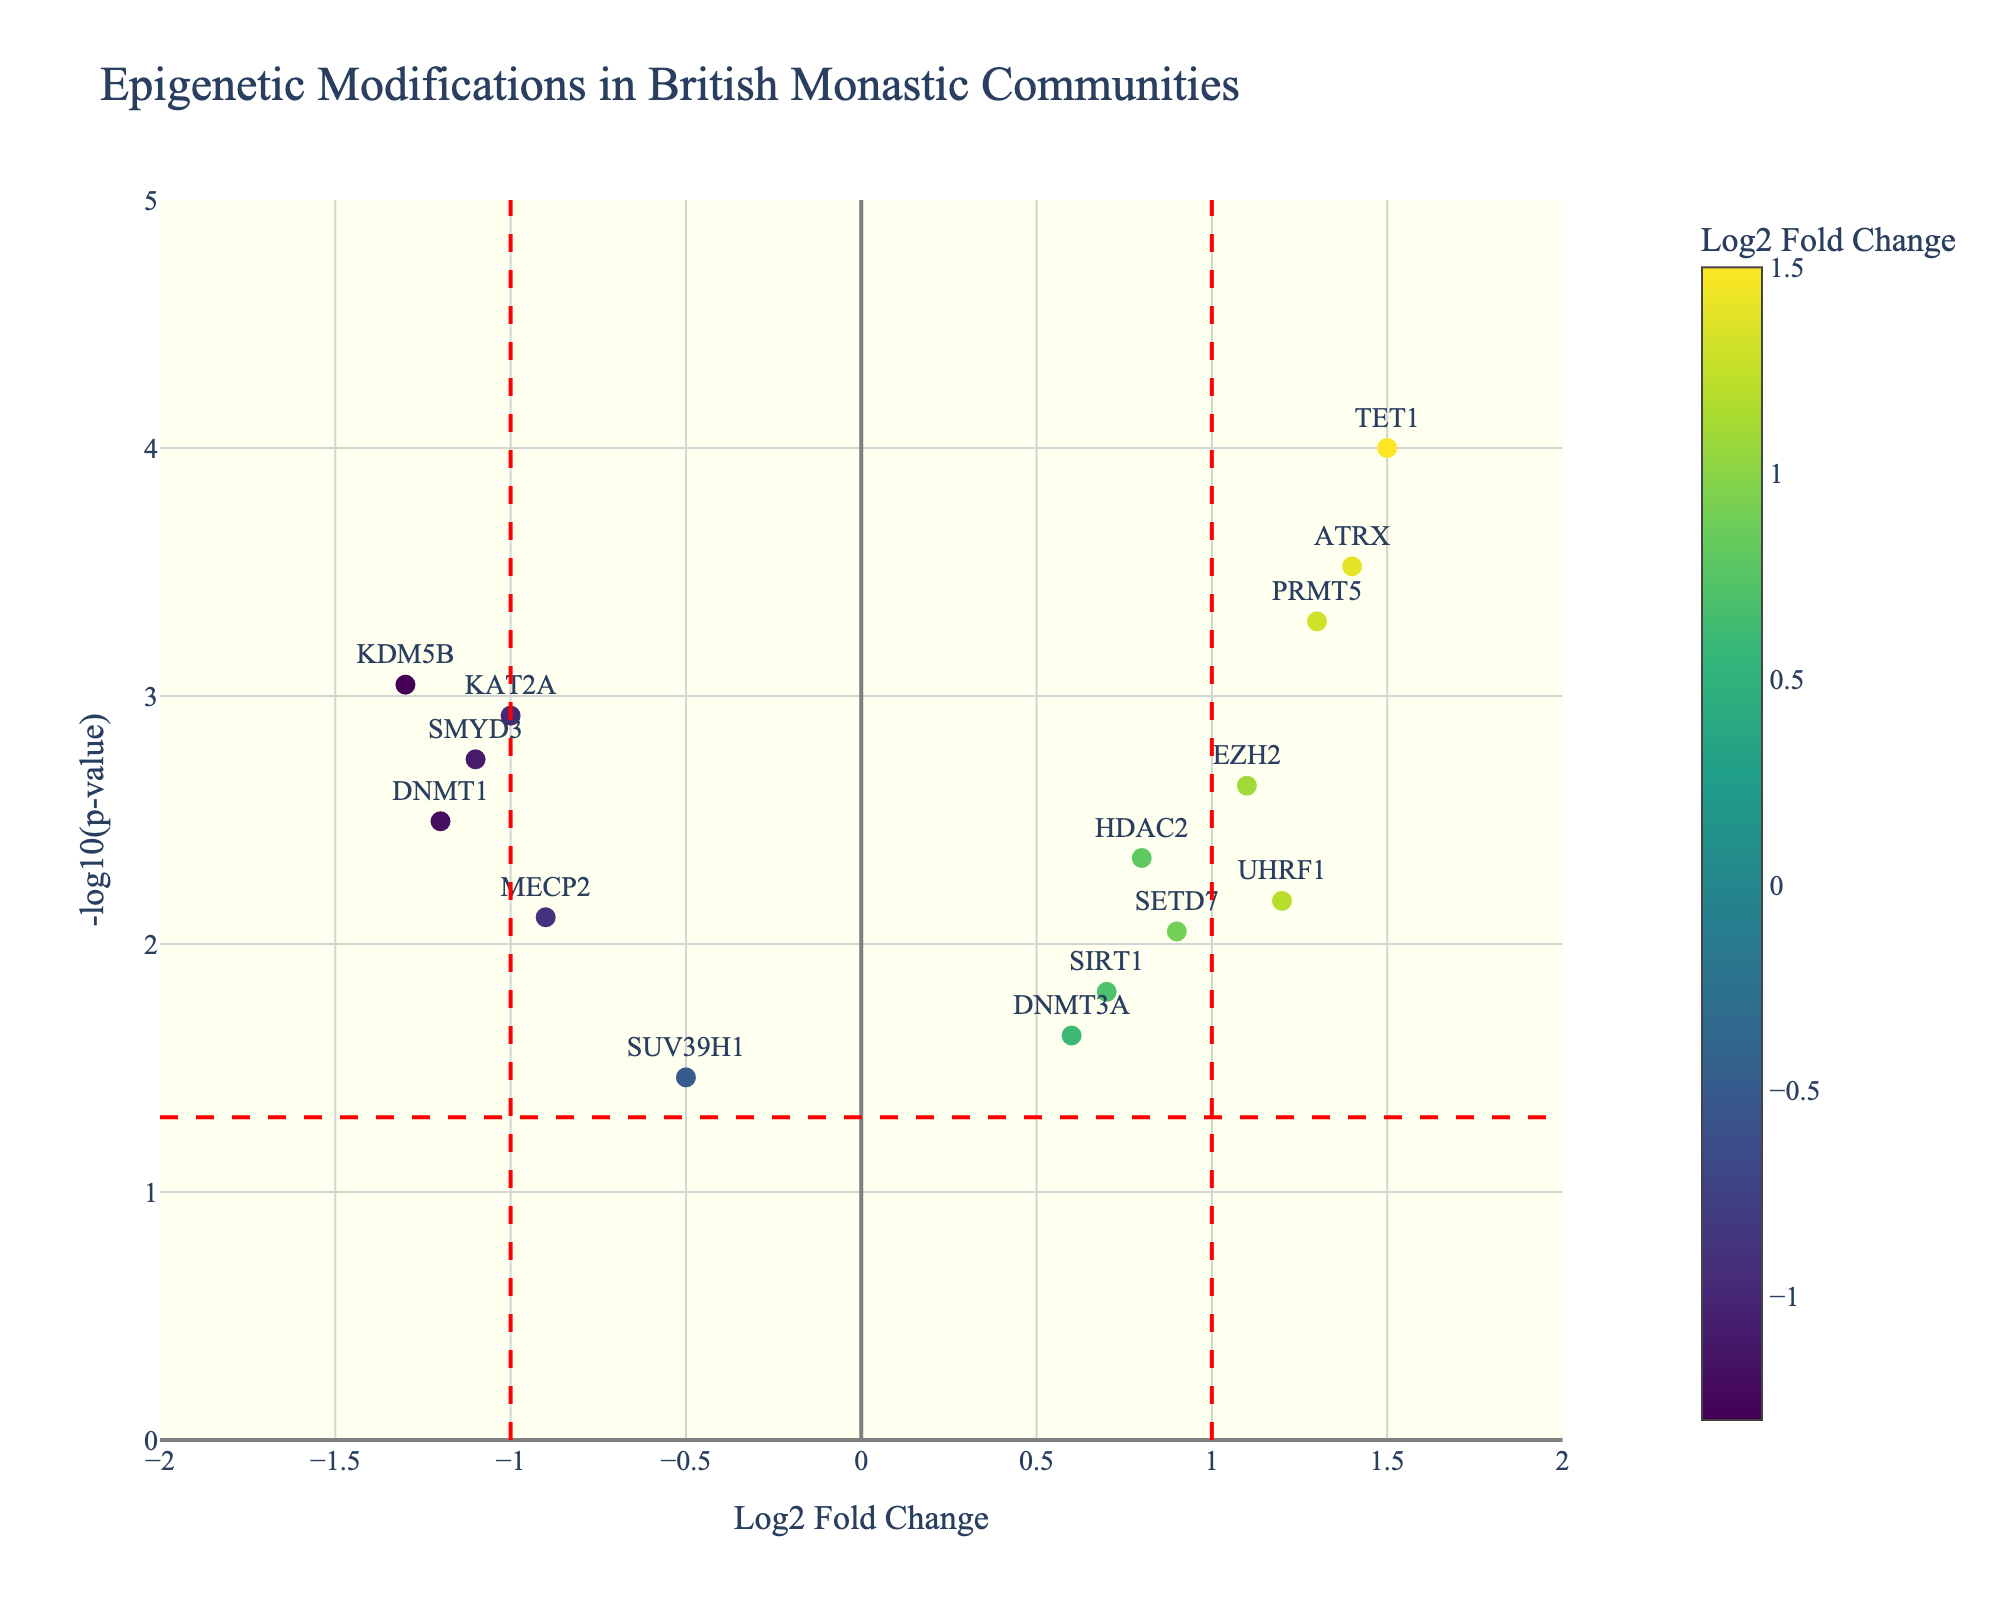Which gene has the highest -log10(p-value) and what is that value? Identify the gene with the highest value on the y-axis and read its y-coordinate. The gene TET1 has the highest -log10(p-value) value, which is around 4.
Answer: TET1, ~4 How many genes have a Log2 Fold Change greater than 1? Count the number of points situated to the right of the x=1 vertical dashed red line. From the plot, the genes with Log2 Fold Change greater than 1 are TET1, EZH2, ATRX, UHRF1, and PRMT5, totaling 5.
Answer: 5 Which gene has the lowest Log2 Fold Change and what is that value? Identify the gene with the lowest x-coordinate on the plot and read its value. The gene KDM5B has the lowest Log2 Fold Change value of -1.3.
Answer: KDM5B, -1.3 Which genes are significantly different, and how can you tell from the plot? Significant genes have a -log10(p-value) greater than -log10(0.05). These genes will be above the horizontal dashed red line. The significant genes include DNMT1, HDAC2, TET1, MECP2, EZH2, KDM5B, UHRF1, KAT2A, SMYD3, and PRMT5.
Answer: DNMT1, HDAC2, TET1, MECP2, EZH2, KDM5B, UHRF1, KAT2A, SMYD3, PRMT5 What trend do you observe concerning the Log2 Fold Change of significantly different genes? Significant genes are colored according to their Log2 Fold Change with positive changes in shades of yellow and negative changes in shades of green. Most significantly different genes tend to have extreme (high or low) Log2 Fold Changes, either above 1 or below -1.
Answer: Extremes in Log2 Fold Change Comparing HDAC2 and MECP2, which has a higher -log10(p-value) and by how much? Check the y-coordinates for HDAC2 and MECP2. HDAC2 has a -log10(p-value) of ~2.35, while MECP2 has ~2.10. The difference is 2.35 - 2.10 = 0.25.
Answer: HDAC2 by 0.25 How many genes have both statistically significant changes and a Log2 Fold Change greater than 1? Look for genes above the horizontal dashed red line and to the right of the x=1 vertical dashed red line. The genes TET1, EZH2, ATRX, and PRMT5 meet these criteria.
Answer: 4 